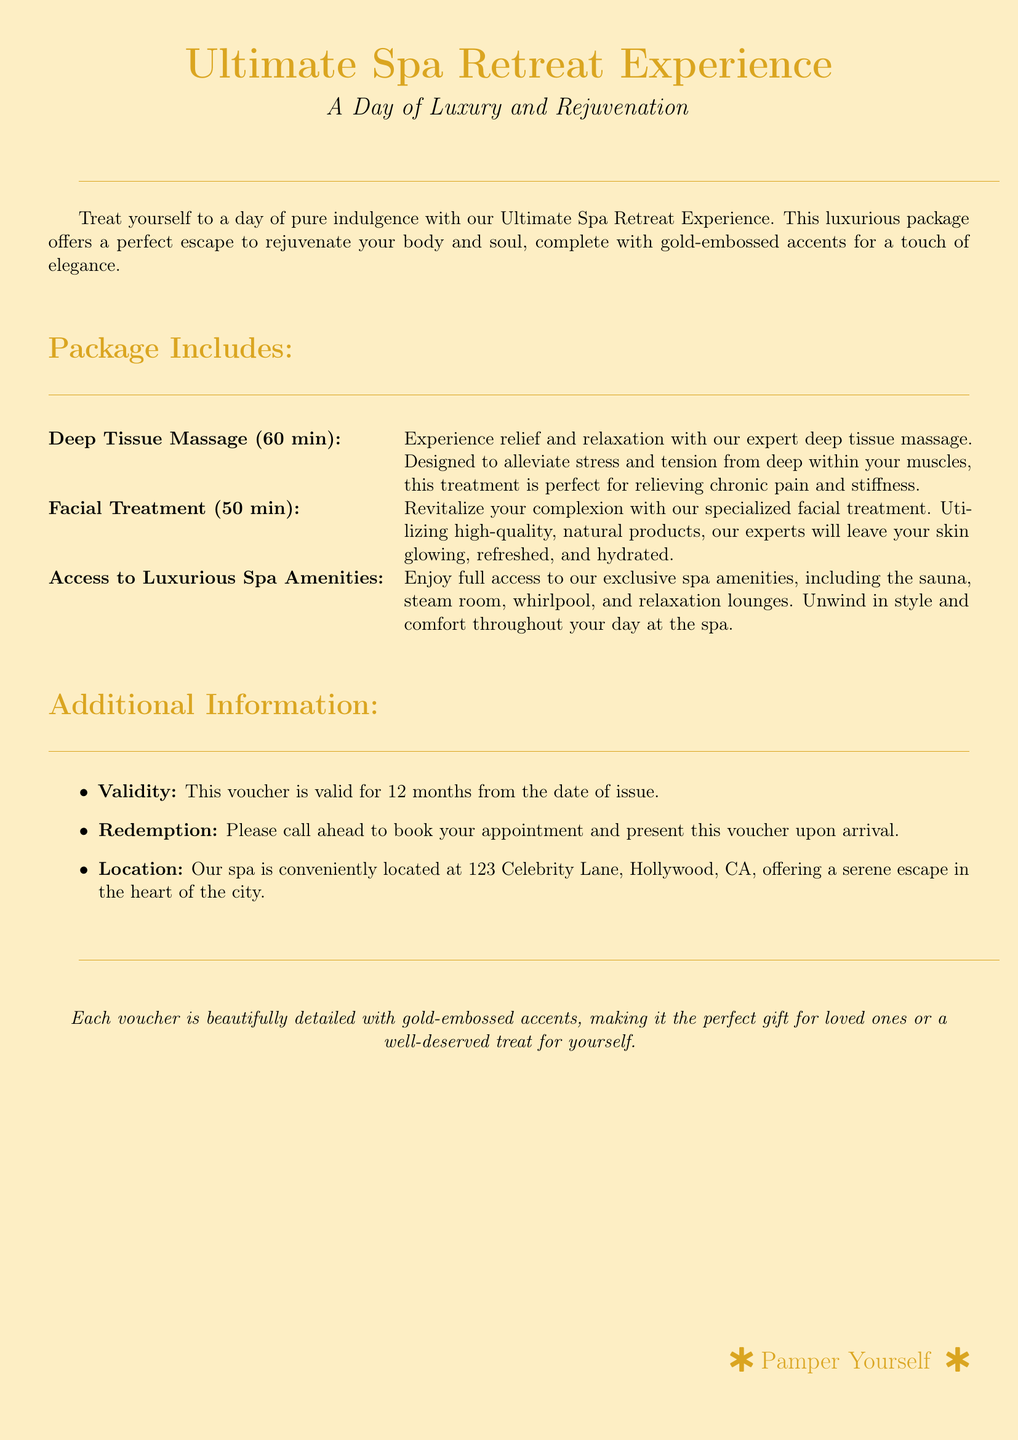What is the title of the experience? The title of the experience is clearly stated at the top of the document.
Answer: Ultimate Spa Retreat Experience What is included in the deep tissue massage? The document specifies the duration and the purpose of the deep tissue massage.
Answer: 60 min How long does the facial treatment last? The duration of the facial treatment is provided in the document.
Answer: 50 min What facilities can you access during the spa experience? The document lists the amenities available for guests.
Answer: Sauna, steam room, whirlpool, relaxation lounges How long is the voucher valid for? The validity period for the voucher is mentioned in the additional information section.
Answer: 12 months What should be done before arriving at the spa? The document provides instructions regarding the appointment.
Answer: Call ahead to book Where is the spa located? The document specifies the location of the spa.
Answer: 123 Celebrity Lane, Hollywood, CA What type of accents does the voucher have? The document describes the design details of the voucher.
Answer: Gold-embossed accents Who is the voucher perfect for? The document hints at the target audience for the gift.
Answer: Loved ones or a well-deserved treat for yourself 